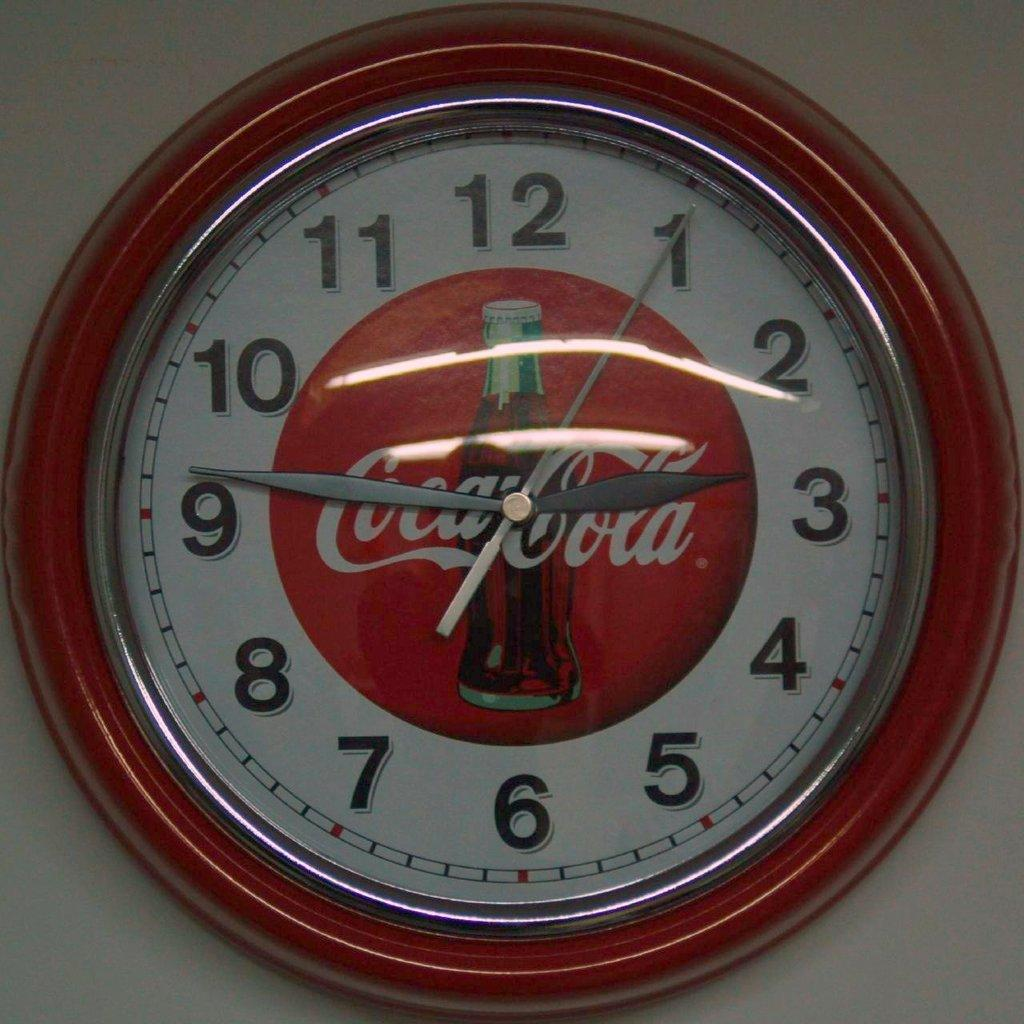<image>
Describe the image concisely. A wall clock with a Coca-Cola logo showing a time of 9:14. 